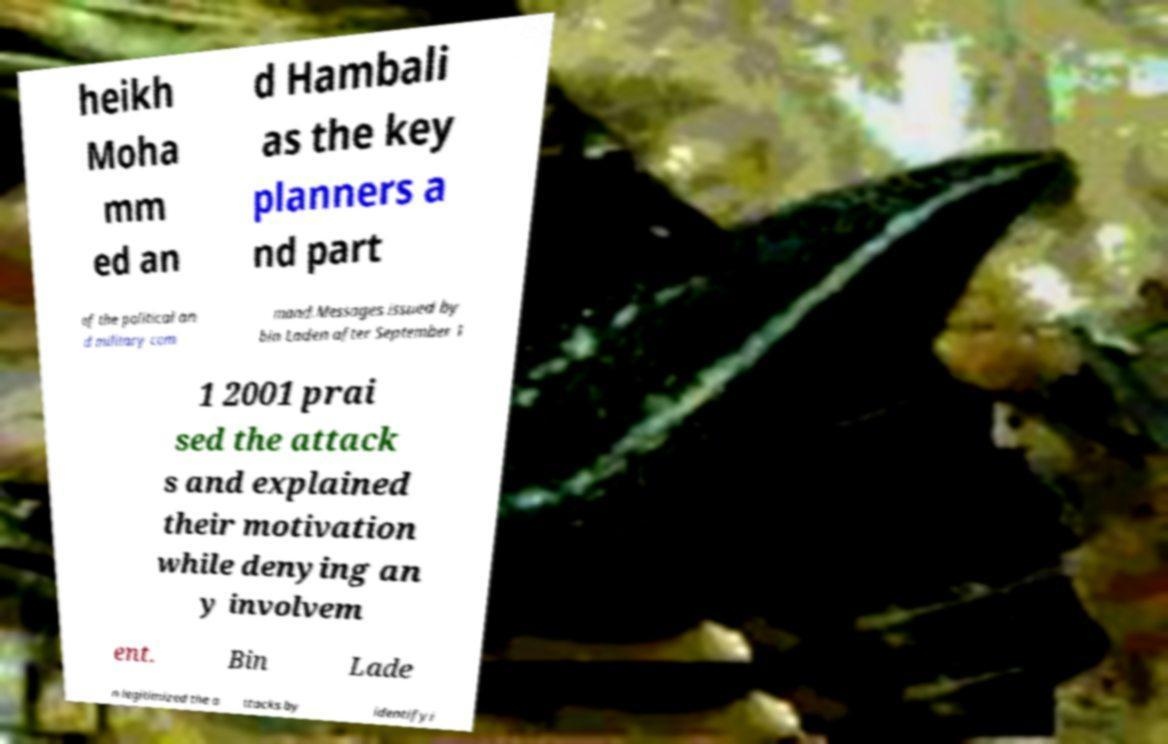Could you assist in decoding the text presented in this image and type it out clearly? heikh Moha mm ed an d Hambali as the key planners a nd part of the political an d military com mand.Messages issued by bin Laden after September 1 1 2001 prai sed the attack s and explained their motivation while denying an y involvem ent. Bin Lade n legitimized the a ttacks by identifyi 